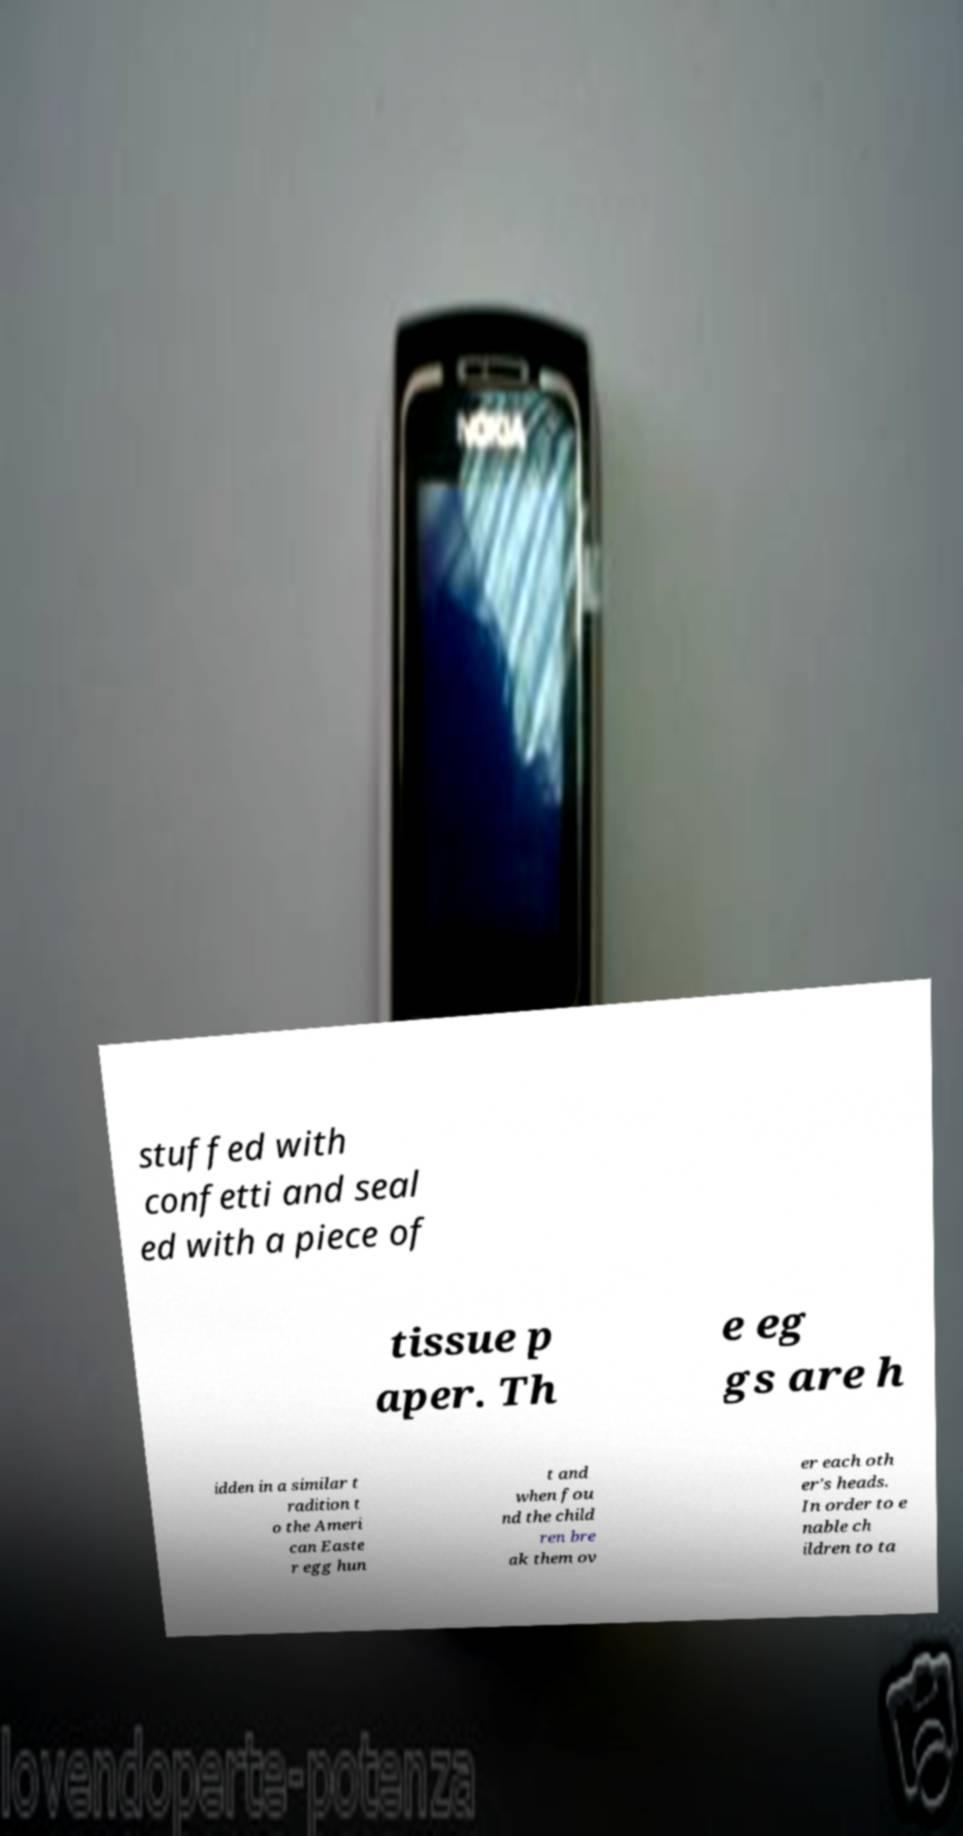Could you assist in decoding the text presented in this image and type it out clearly? stuffed with confetti and seal ed with a piece of tissue p aper. Th e eg gs are h idden in a similar t radition t o the Ameri can Easte r egg hun t and when fou nd the child ren bre ak them ov er each oth er's heads. In order to e nable ch ildren to ta 